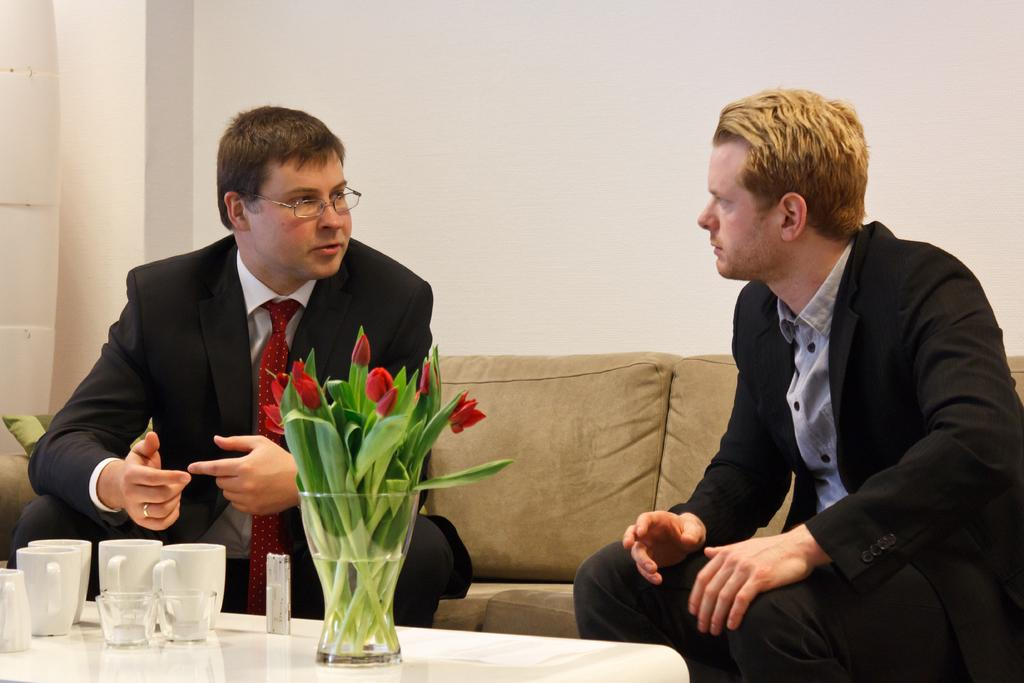What objects are on the table in the image? There are cups and a flower flask on the table in the image. What is the color of the wall in the background of the image? There is a white wall in the background of the image. How many people are sitting on the sofa in the image? There are two people sitting on a brown sofa in the image. What type of straw is being used to decorate the cups in the image? There is no straw present in the image; the cups are not being decorated with any straw. What country is depicted in the image? The image does not depict any specific country; it is a scene of cups, a flower flask, a table, a sofa, and people. 